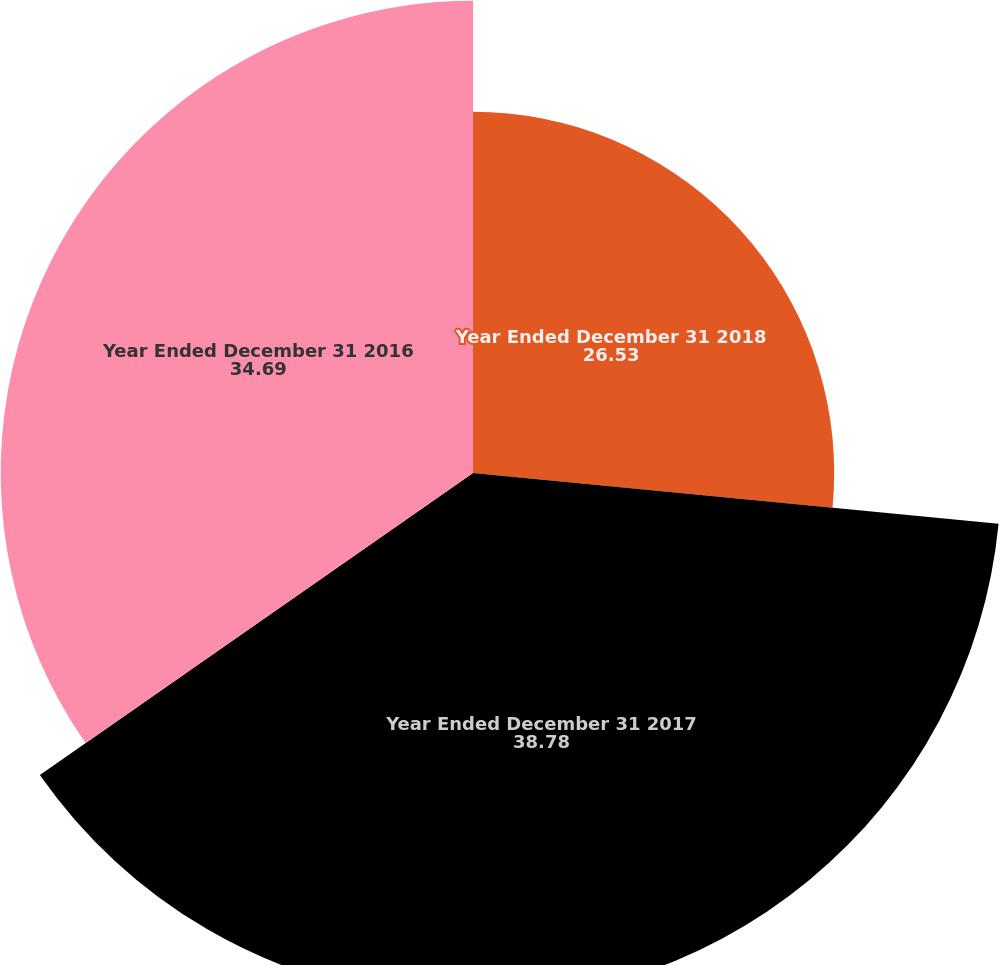Convert chart to OTSL. <chart><loc_0><loc_0><loc_500><loc_500><pie_chart><fcel>Year Ended December 31 2018<fcel>Year Ended December 31 2017<fcel>Year Ended December 31 2016<nl><fcel>26.53%<fcel>38.78%<fcel>34.69%<nl></chart> 